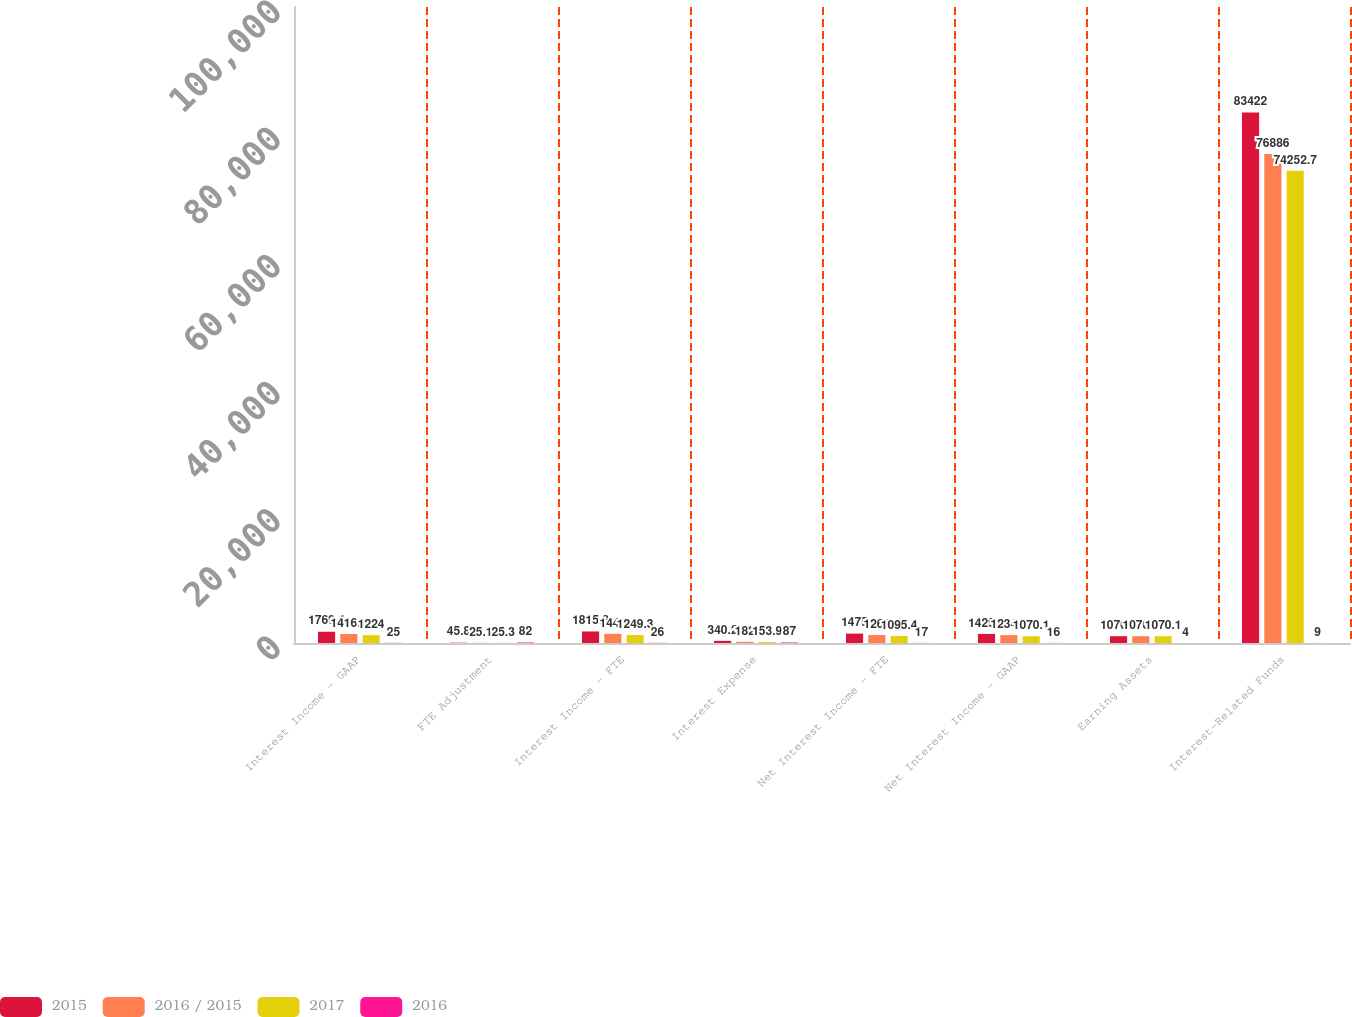Convert chart. <chart><loc_0><loc_0><loc_500><loc_500><stacked_bar_chart><ecel><fcel>Interest Income - GAAP<fcel>FTE Adjustment<fcel>Interest Income - FTE<fcel>Interest Expense<fcel>Net Interest Income - FTE<fcel>Net Interest Income - GAAP<fcel>Earning Assets<fcel>Interest-Related Funds<nl><fcel>2015<fcel>1769.4<fcel>45.8<fcel>1815.2<fcel>340.2<fcel>1475<fcel>1429.2<fcel>1070.1<fcel>83422<nl><fcel>2016 / 2015<fcel>1416.9<fcel>25.1<fcel>1442<fcel>182<fcel>1260<fcel>1234.9<fcel>1070.1<fcel>76886<nl><fcel>2017<fcel>1224<fcel>25.3<fcel>1249.3<fcel>153.9<fcel>1095.4<fcel>1070.1<fcel>1070.1<fcel>74252.7<nl><fcel>2016<fcel>25<fcel>82<fcel>26<fcel>87<fcel>17<fcel>16<fcel>4<fcel>9<nl></chart> 